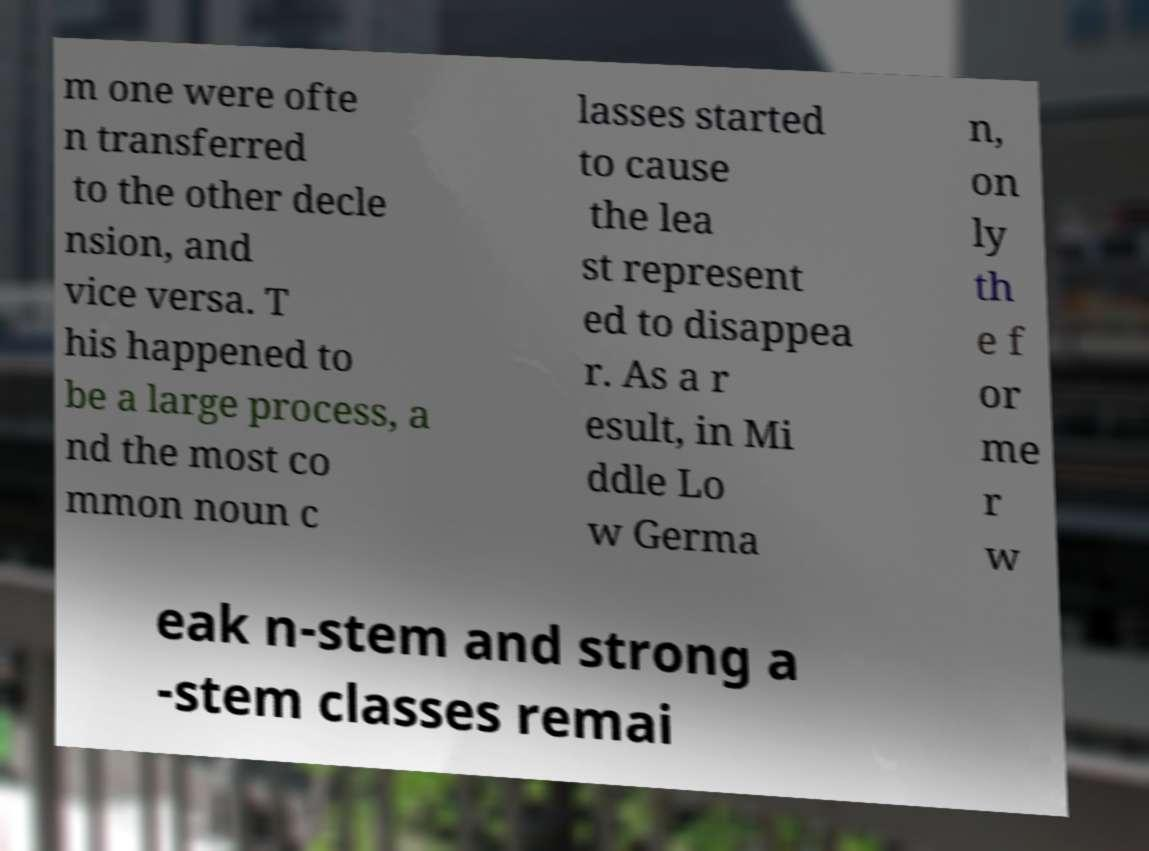There's text embedded in this image that I need extracted. Can you transcribe it verbatim? m one were ofte n transferred to the other decle nsion, and vice versa. T his happened to be a large process, a nd the most co mmon noun c lasses started to cause the lea st represent ed to disappea r. As a r esult, in Mi ddle Lo w Germa n, on ly th e f or me r w eak n-stem and strong a -stem classes remai 